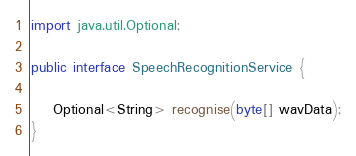<code> <loc_0><loc_0><loc_500><loc_500><_Java_>import java.util.Optional;

public interface SpeechRecognitionService {

    Optional<String> recognise(byte[] wavData);
}
</code> 